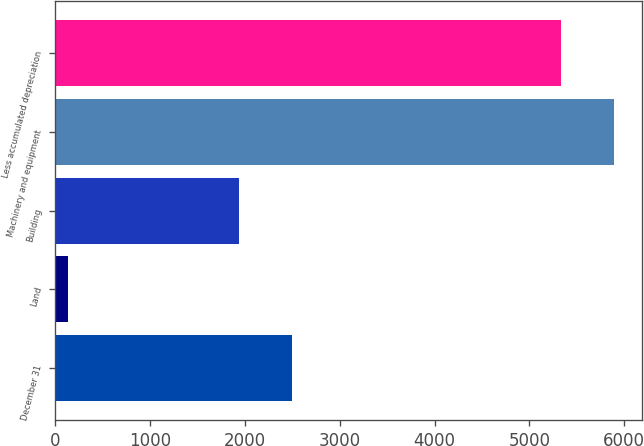<chart> <loc_0><loc_0><loc_500><loc_500><bar_chart><fcel>December 31<fcel>Land<fcel>Building<fcel>Machinery and equipment<fcel>Less accumulated depreciation<nl><fcel>2495.1<fcel>134<fcel>1934<fcel>5894.1<fcel>5333<nl></chart> 